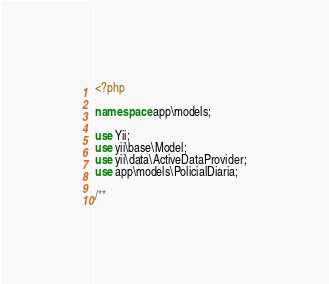Convert code to text. <code><loc_0><loc_0><loc_500><loc_500><_PHP_><?php

namespace app\models;

use Yii;
use yii\base\Model;
use yii\data\ActiveDataProvider;
use app\models\PolicialDiaria;

/**</code> 